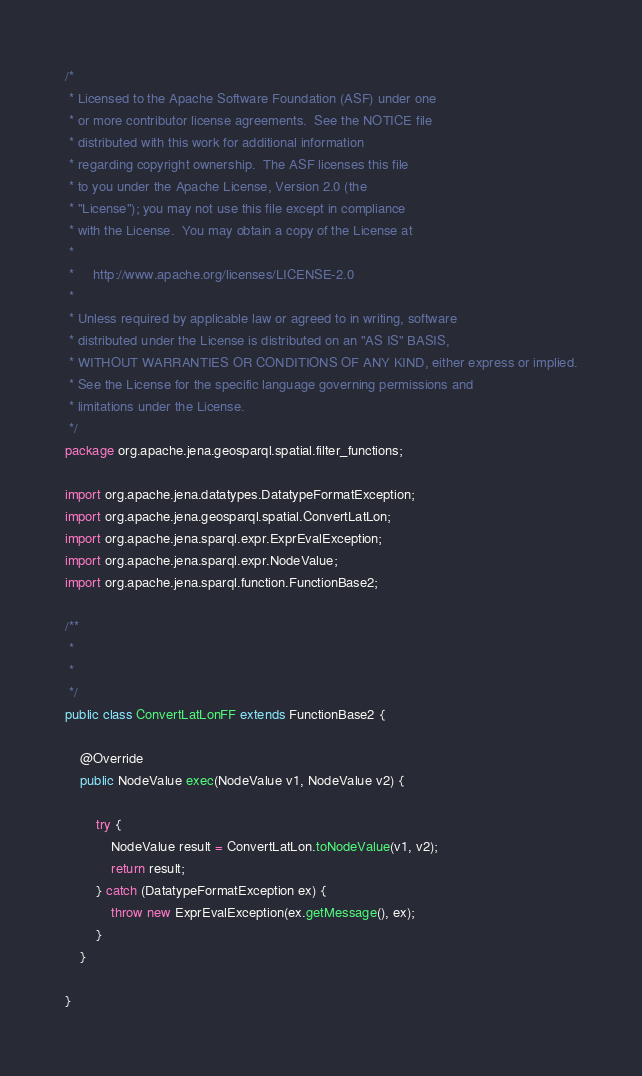<code> <loc_0><loc_0><loc_500><loc_500><_Java_>/*
 * Licensed to the Apache Software Foundation (ASF) under one
 * or more contributor license agreements.  See the NOTICE file
 * distributed with this work for additional information
 * regarding copyright ownership.  The ASF licenses this file
 * to you under the Apache License, Version 2.0 (the
 * "License"); you may not use this file except in compliance
 * with the License.  You may obtain a copy of the License at
 *
 *     http://www.apache.org/licenses/LICENSE-2.0
 *
 * Unless required by applicable law or agreed to in writing, software
 * distributed under the License is distributed on an "AS IS" BASIS,
 * WITHOUT WARRANTIES OR CONDITIONS OF ANY KIND, either express or implied.
 * See the License for the specific language governing permissions and
 * limitations under the License.
 */
package org.apache.jena.geosparql.spatial.filter_functions;

import org.apache.jena.datatypes.DatatypeFormatException;
import org.apache.jena.geosparql.spatial.ConvertLatLon;
import org.apache.jena.sparql.expr.ExprEvalException;
import org.apache.jena.sparql.expr.NodeValue;
import org.apache.jena.sparql.function.FunctionBase2;

/**
 *
 *
 */
public class ConvertLatLonFF extends FunctionBase2 {

    @Override
    public NodeValue exec(NodeValue v1, NodeValue v2) {

        try {
            NodeValue result = ConvertLatLon.toNodeValue(v1, v2);
            return result;
        } catch (DatatypeFormatException ex) {
            throw new ExprEvalException(ex.getMessage(), ex);
        }
    }

}
</code> 